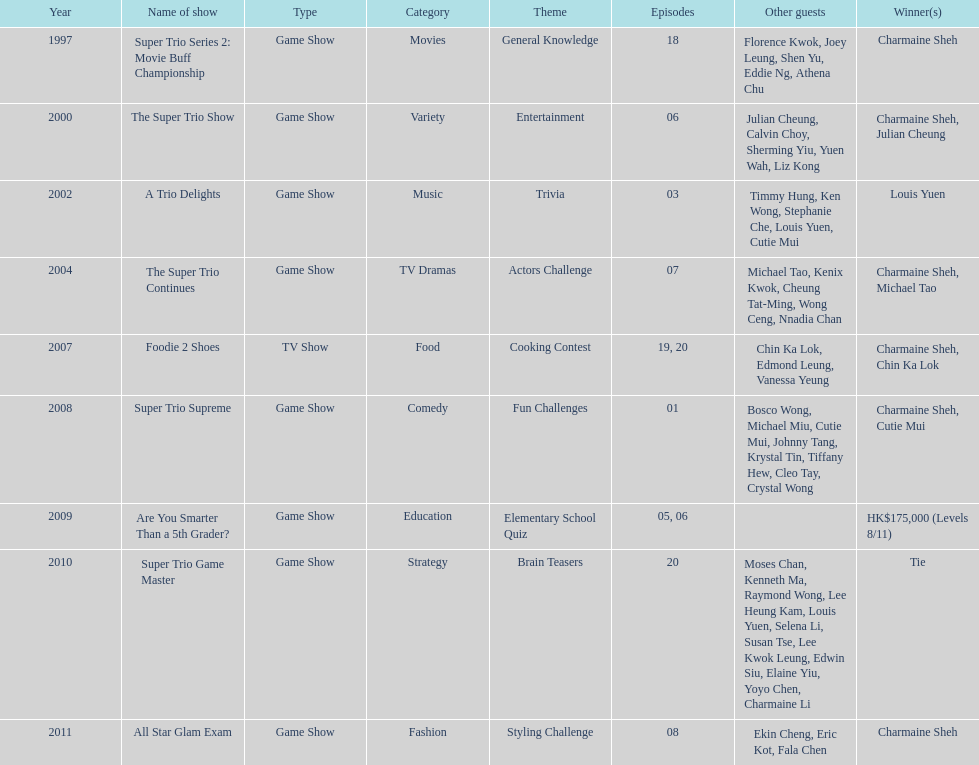What is the number of tv shows that charmaine sheh has appeared on? 9. 